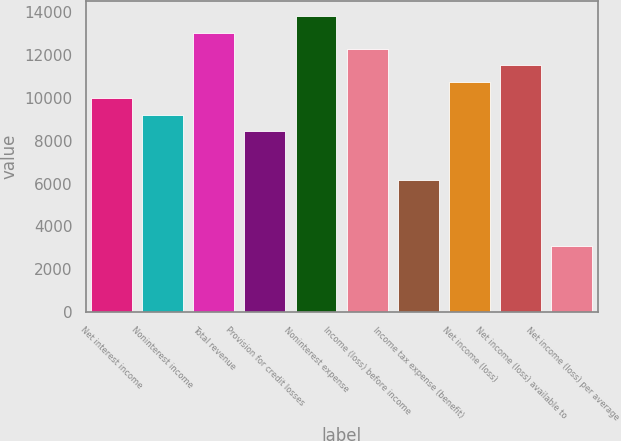Convert chart. <chart><loc_0><loc_0><loc_500><loc_500><bar_chart><fcel>Net interest income<fcel>Noninterest income<fcel>Total revenue<fcel>Provision for credit losses<fcel>Noninterest expense<fcel>Income (loss) before income<fcel>Income tax expense (benefit)<fcel>Net income (loss)<fcel>Net income (loss) available to<fcel>Net income (loss) per average<nl><fcel>9982.09<fcel>9214.4<fcel>13052.9<fcel>8446.71<fcel>13820.5<fcel>12285.2<fcel>6143.64<fcel>10749.8<fcel>11517.5<fcel>3072.88<nl></chart> 